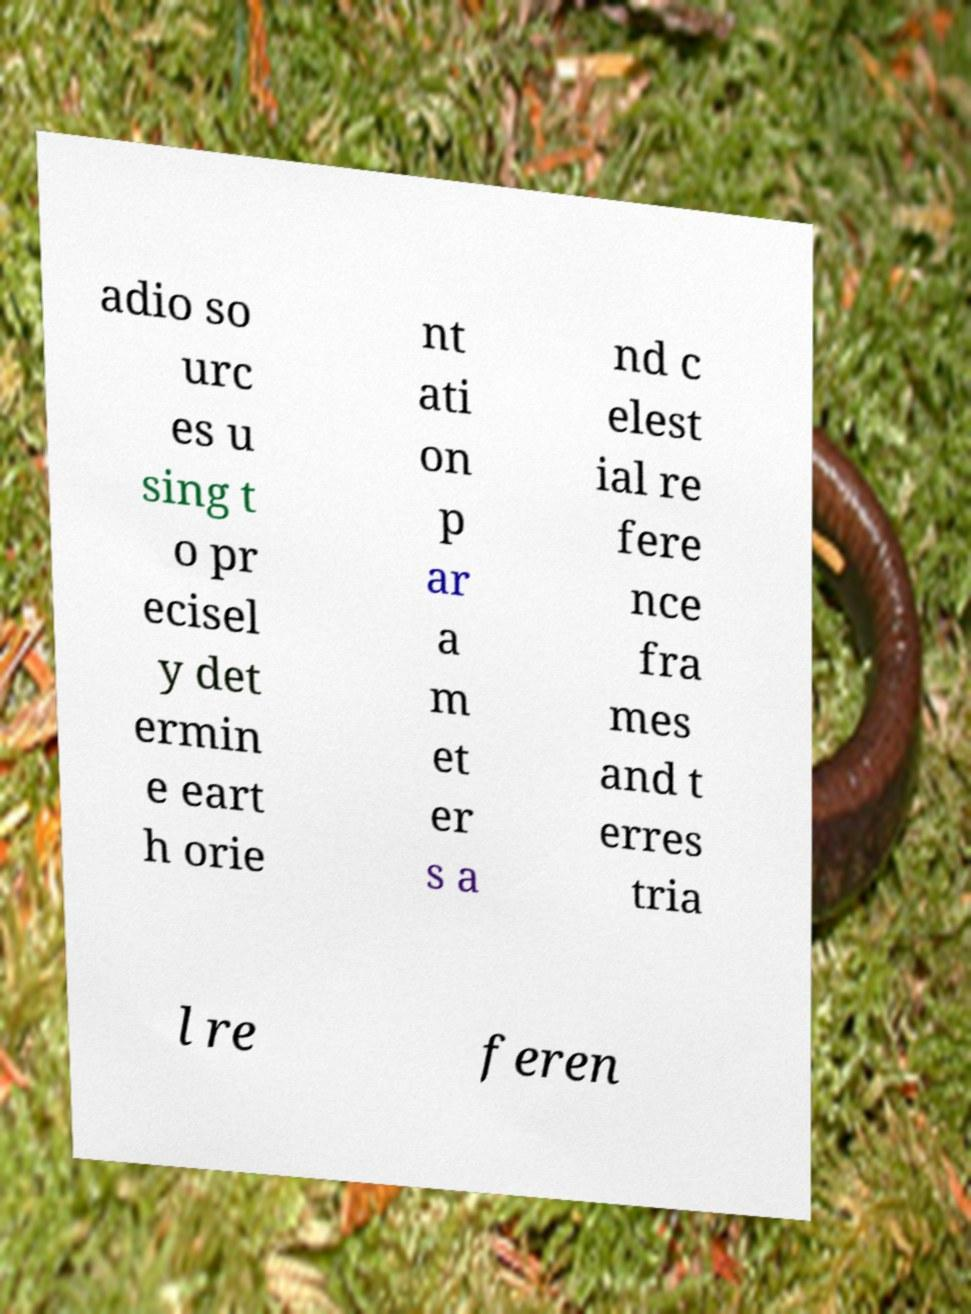What messages or text are displayed in this image? I need them in a readable, typed format. adio so urc es u sing t o pr ecisel y det ermin e eart h orie nt ati on p ar a m et er s a nd c elest ial re fere nce fra mes and t erres tria l re feren 